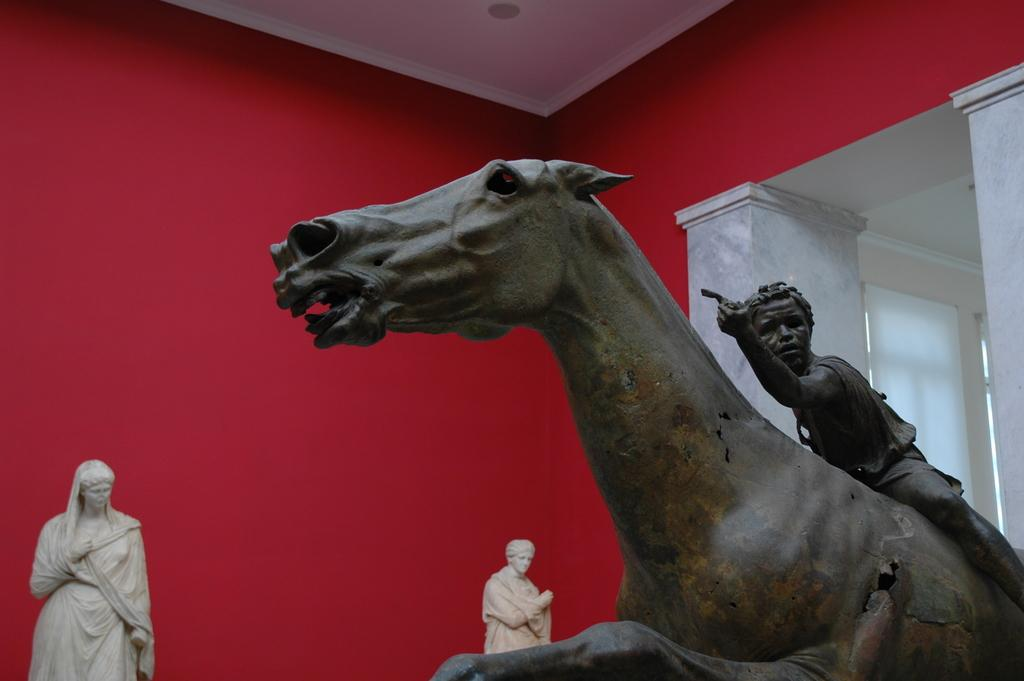What type of objects can be seen in the image? There are statues in the image. Can you describe the appearance of the statues? The statues are in brown and cream color. What is the color of the background wall in the image? The background wall is in red and white color. Are there any ghosts or mist visible in the image? No, there are no ghosts or mist present in the image; it only features statues and a background wall. 